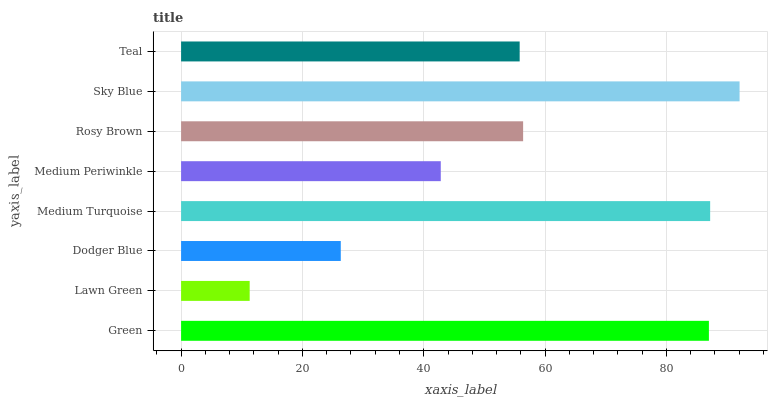Is Lawn Green the minimum?
Answer yes or no. Yes. Is Sky Blue the maximum?
Answer yes or no. Yes. Is Dodger Blue the minimum?
Answer yes or no. No. Is Dodger Blue the maximum?
Answer yes or no. No. Is Dodger Blue greater than Lawn Green?
Answer yes or no. Yes. Is Lawn Green less than Dodger Blue?
Answer yes or no. Yes. Is Lawn Green greater than Dodger Blue?
Answer yes or no. No. Is Dodger Blue less than Lawn Green?
Answer yes or no. No. Is Rosy Brown the high median?
Answer yes or no. Yes. Is Teal the low median?
Answer yes or no. Yes. Is Green the high median?
Answer yes or no. No. Is Rosy Brown the low median?
Answer yes or no. No. 